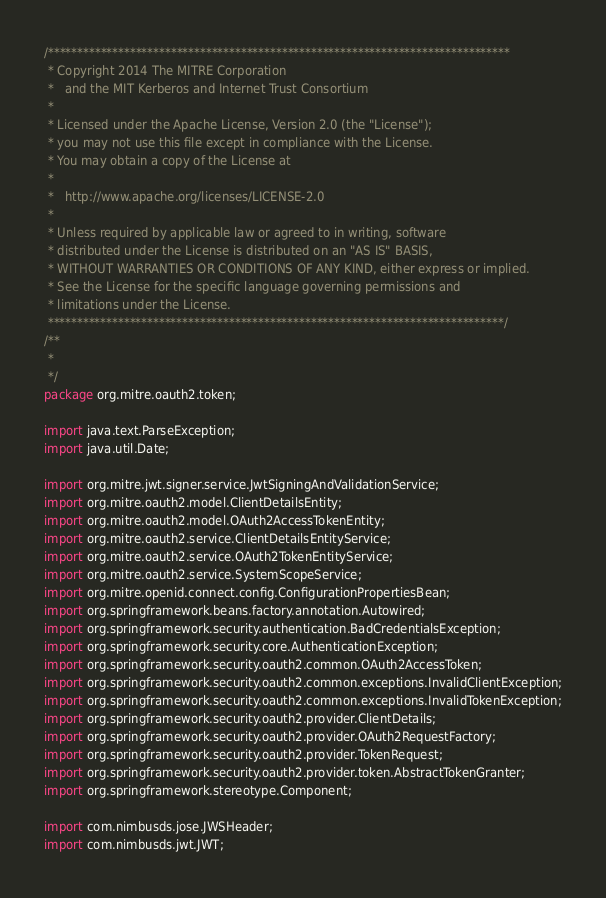Convert code to text. <code><loc_0><loc_0><loc_500><loc_500><_Java_>/*******************************************************************************
 * Copyright 2014 The MITRE Corporation
 *   and the MIT Kerberos and Internet Trust Consortium
 * 
 * Licensed under the Apache License, Version 2.0 (the "License");
 * you may not use this file except in compliance with the License.
 * You may obtain a copy of the License at
 * 
 *   http://www.apache.org/licenses/LICENSE-2.0
 * 
 * Unless required by applicable law or agreed to in writing, software
 * distributed under the License is distributed on an "AS IS" BASIS,
 * WITHOUT WARRANTIES OR CONDITIONS OF ANY KIND, either express or implied.
 * See the License for the specific language governing permissions and
 * limitations under the License.
 ******************************************************************************/
/**
 * 
 */
package org.mitre.oauth2.token;

import java.text.ParseException;
import java.util.Date;

import org.mitre.jwt.signer.service.JwtSigningAndValidationService;
import org.mitre.oauth2.model.ClientDetailsEntity;
import org.mitre.oauth2.model.OAuth2AccessTokenEntity;
import org.mitre.oauth2.service.ClientDetailsEntityService;
import org.mitre.oauth2.service.OAuth2TokenEntityService;
import org.mitre.oauth2.service.SystemScopeService;
import org.mitre.openid.connect.config.ConfigurationPropertiesBean;
import org.springframework.beans.factory.annotation.Autowired;
import org.springframework.security.authentication.BadCredentialsException;
import org.springframework.security.core.AuthenticationException;
import org.springframework.security.oauth2.common.OAuth2AccessToken;
import org.springframework.security.oauth2.common.exceptions.InvalidClientException;
import org.springframework.security.oauth2.common.exceptions.InvalidTokenException;
import org.springframework.security.oauth2.provider.ClientDetails;
import org.springframework.security.oauth2.provider.OAuth2RequestFactory;
import org.springframework.security.oauth2.provider.TokenRequest;
import org.springframework.security.oauth2.provider.token.AbstractTokenGranter;
import org.springframework.stereotype.Component;

import com.nimbusds.jose.JWSHeader;
import com.nimbusds.jwt.JWT;</code> 